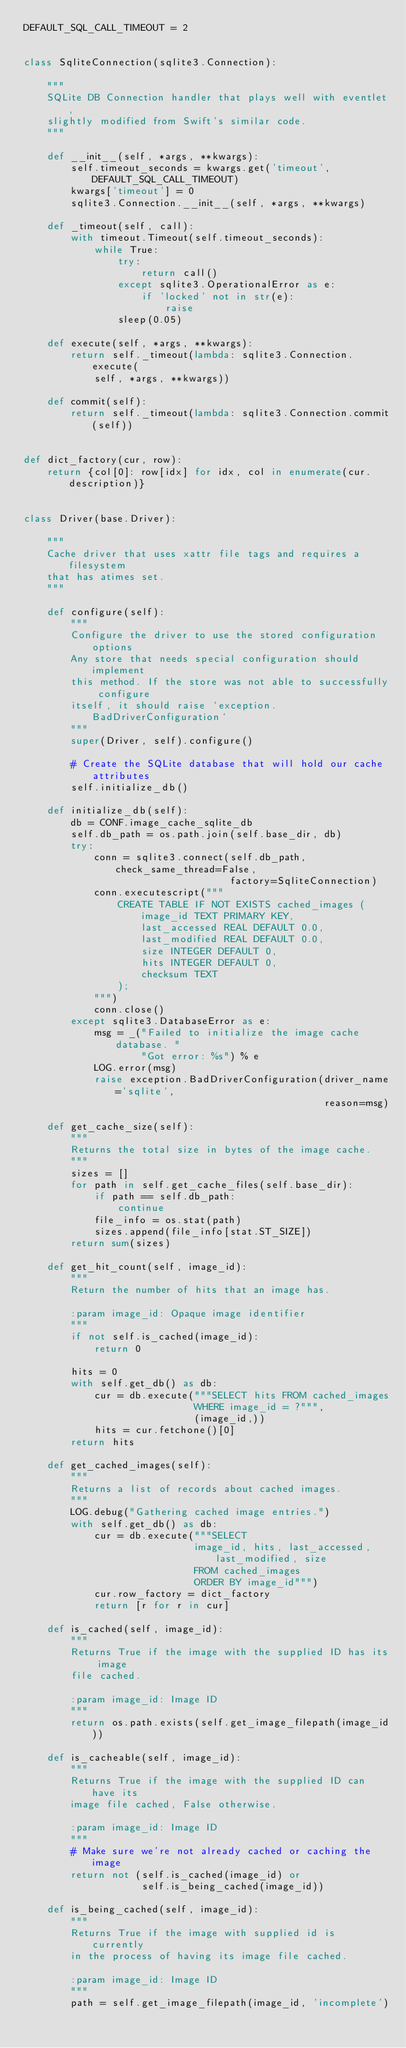Convert code to text. <code><loc_0><loc_0><loc_500><loc_500><_Python_>DEFAULT_SQL_CALL_TIMEOUT = 2


class SqliteConnection(sqlite3.Connection):

    """
    SQLite DB Connection handler that plays well with eventlet,
    slightly modified from Swift's similar code.
    """

    def __init__(self, *args, **kwargs):
        self.timeout_seconds = kwargs.get('timeout', DEFAULT_SQL_CALL_TIMEOUT)
        kwargs['timeout'] = 0
        sqlite3.Connection.__init__(self, *args, **kwargs)

    def _timeout(self, call):
        with timeout.Timeout(self.timeout_seconds):
            while True:
                try:
                    return call()
                except sqlite3.OperationalError as e:
                    if 'locked' not in str(e):
                        raise
                sleep(0.05)

    def execute(self, *args, **kwargs):
        return self._timeout(lambda: sqlite3.Connection.execute(
            self, *args, **kwargs))

    def commit(self):
        return self._timeout(lambda: sqlite3.Connection.commit(self))


def dict_factory(cur, row):
    return {col[0]: row[idx] for idx, col in enumerate(cur.description)}


class Driver(base.Driver):

    """
    Cache driver that uses xattr file tags and requires a filesystem
    that has atimes set.
    """

    def configure(self):
        """
        Configure the driver to use the stored configuration options
        Any store that needs special configuration should implement
        this method. If the store was not able to successfully configure
        itself, it should raise `exception.BadDriverConfiguration`
        """
        super(Driver, self).configure()

        # Create the SQLite database that will hold our cache attributes
        self.initialize_db()

    def initialize_db(self):
        db = CONF.image_cache_sqlite_db
        self.db_path = os.path.join(self.base_dir, db)
        try:
            conn = sqlite3.connect(self.db_path, check_same_thread=False,
                                   factory=SqliteConnection)
            conn.executescript("""
                CREATE TABLE IF NOT EXISTS cached_images (
                    image_id TEXT PRIMARY KEY,
                    last_accessed REAL DEFAULT 0.0,
                    last_modified REAL DEFAULT 0.0,
                    size INTEGER DEFAULT 0,
                    hits INTEGER DEFAULT 0,
                    checksum TEXT
                );
            """)
            conn.close()
        except sqlite3.DatabaseError as e:
            msg = _("Failed to initialize the image cache database. "
                    "Got error: %s") % e
            LOG.error(msg)
            raise exception.BadDriverConfiguration(driver_name='sqlite',
                                                   reason=msg)

    def get_cache_size(self):
        """
        Returns the total size in bytes of the image cache.
        """
        sizes = []
        for path in self.get_cache_files(self.base_dir):
            if path == self.db_path:
                continue
            file_info = os.stat(path)
            sizes.append(file_info[stat.ST_SIZE])
        return sum(sizes)

    def get_hit_count(self, image_id):
        """
        Return the number of hits that an image has.

        :param image_id: Opaque image identifier
        """
        if not self.is_cached(image_id):
            return 0

        hits = 0
        with self.get_db() as db:
            cur = db.execute("""SELECT hits FROM cached_images
                             WHERE image_id = ?""",
                             (image_id,))
            hits = cur.fetchone()[0]
        return hits

    def get_cached_images(self):
        """
        Returns a list of records about cached images.
        """
        LOG.debug("Gathering cached image entries.")
        with self.get_db() as db:
            cur = db.execute("""SELECT
                             image_id, hits, last_accessed, last_modified, size
                             FROM cached_images
                             ORDER BY image_id""")
            cur.row_factory = dict_factory
            return [r for r in cur]

    def is_cached(self, image_id):
        """
        Returns True if the image with the supplied ID has its image
        file cached.

        :param image_id: Image ID
        """
        return os.path.exists(self.get_image_filepath(image_id))

    def is_cacheable(self, image_id):
        """
        Returns True if the image with the supplied ID can have its
        image file cached, False otherwise.

        :param image_id: Image ID
        """
        # Make sure we're not already cached or caching the image
        return not (self.is_cached(image_id) or
                    self.is_being_cached(image_id))

    def is_being_cached(self, image_id):
        """
        Returns True if the image with supplied id is currently
        in the process of having its image file cached.

        :param image_id: Image ID
        """
        path = self.get_image_filepath(image_id, 'incomplete')</code> 